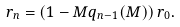<formula> <loc_0><loc_0><loc_500><loc_500>r _ { n } = \left ( 1 - M q _ { n - 1 } ( M ) \right ) r _ { 0 } .</formula> 